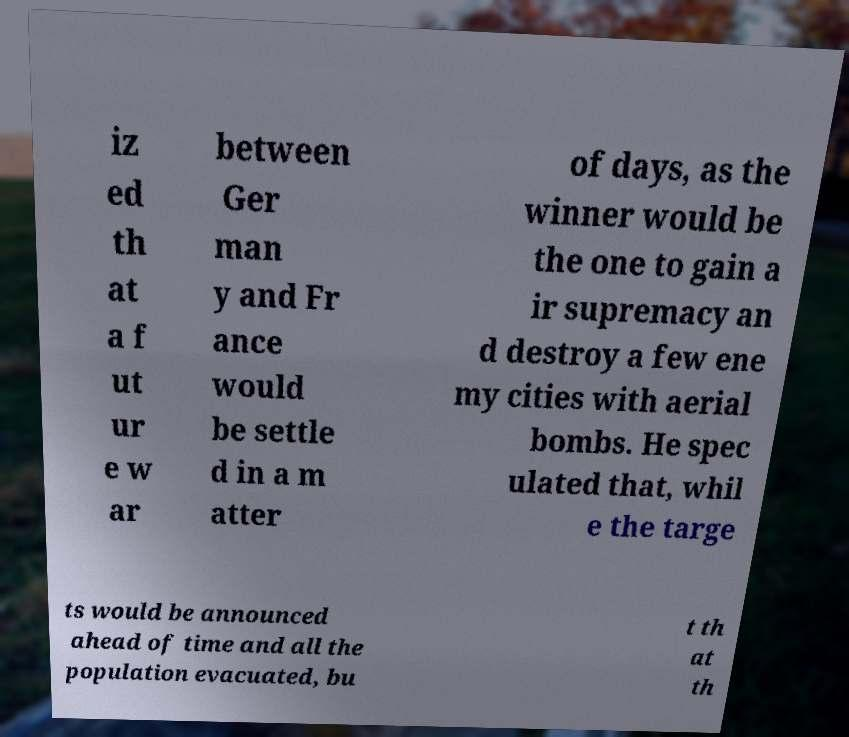Please read and relay the text visible in this image. What does it say? iz ed th at a f ut ur e w ar between Ger man y and Fr ance would be settle d in a m atter of days, as the winner would be the one to gain a ir supremacy an d destroy a few ene my cities with aerial bombs. He spec ulated that, whil e the targe ts would be announced ahead of time and all the population evacuated, bu t th at th 